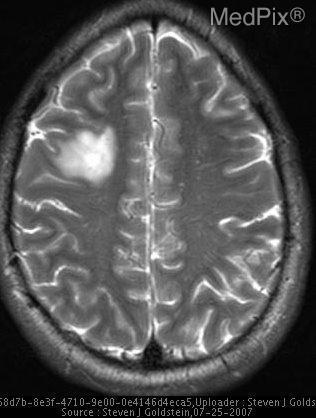Is there mass effect from the lesion?
Be succinct. No. What lobe of the brain is the lesion located in?
Quick response, please. Right frontal lobe. Where is the brain lesion located?
Quick response, please. Right frontal lobe. What mri imaging sequence is shown above?
Concise answer only. T2 weighted. What type of mri is shown in the above image?
Answer briefly. T2 weighted. Does the lesion above enhance?
Short answer required. No. Is there enhancement of the lesion?
Give a very brief answer. No. 